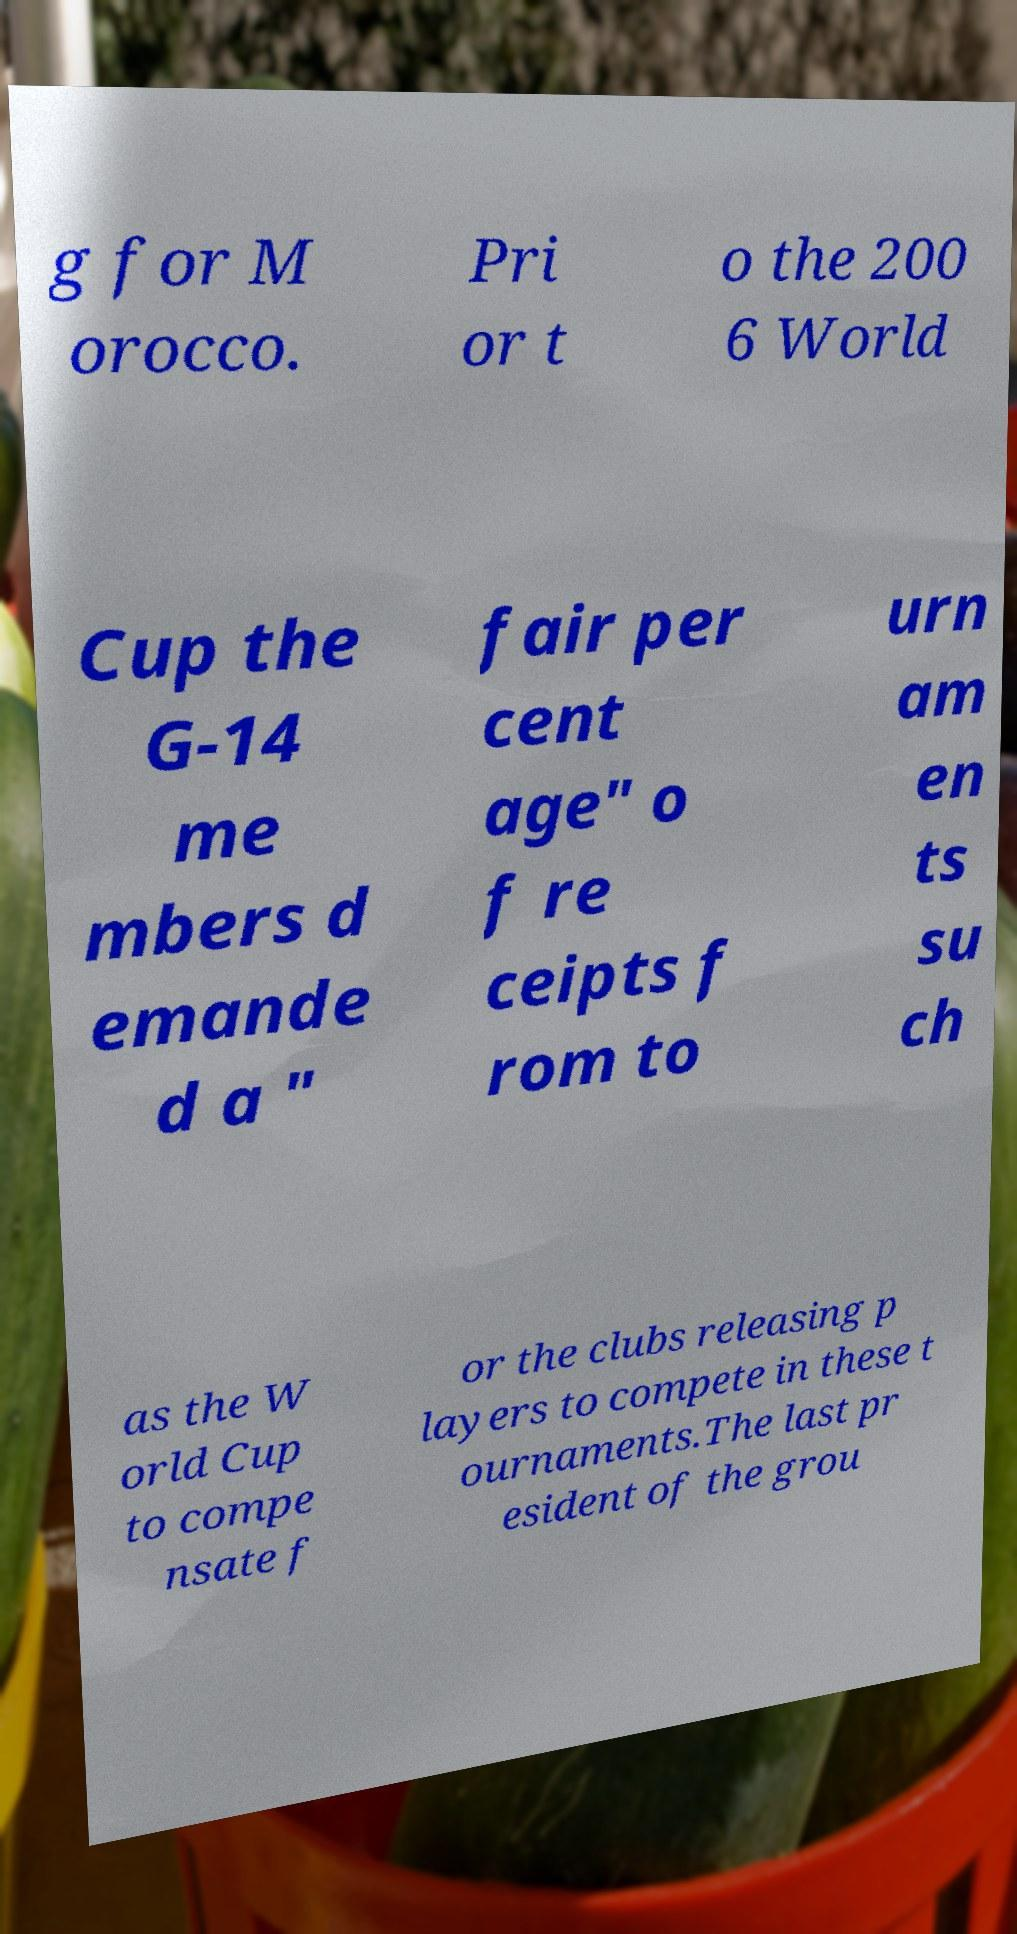What messages or text are displayed in this image? I need them in a readable, typed format. g for M orocco. Pri or t o the 200 6 World Cup the G-14 me mbers d emande d a " fair per cent age" o f re ceipts f rom to urn am en ts su ch as the W orld Cup to compe nsate f or the clubs releasing p layers to compete in these t ournaments.The last pr esident of the grou 